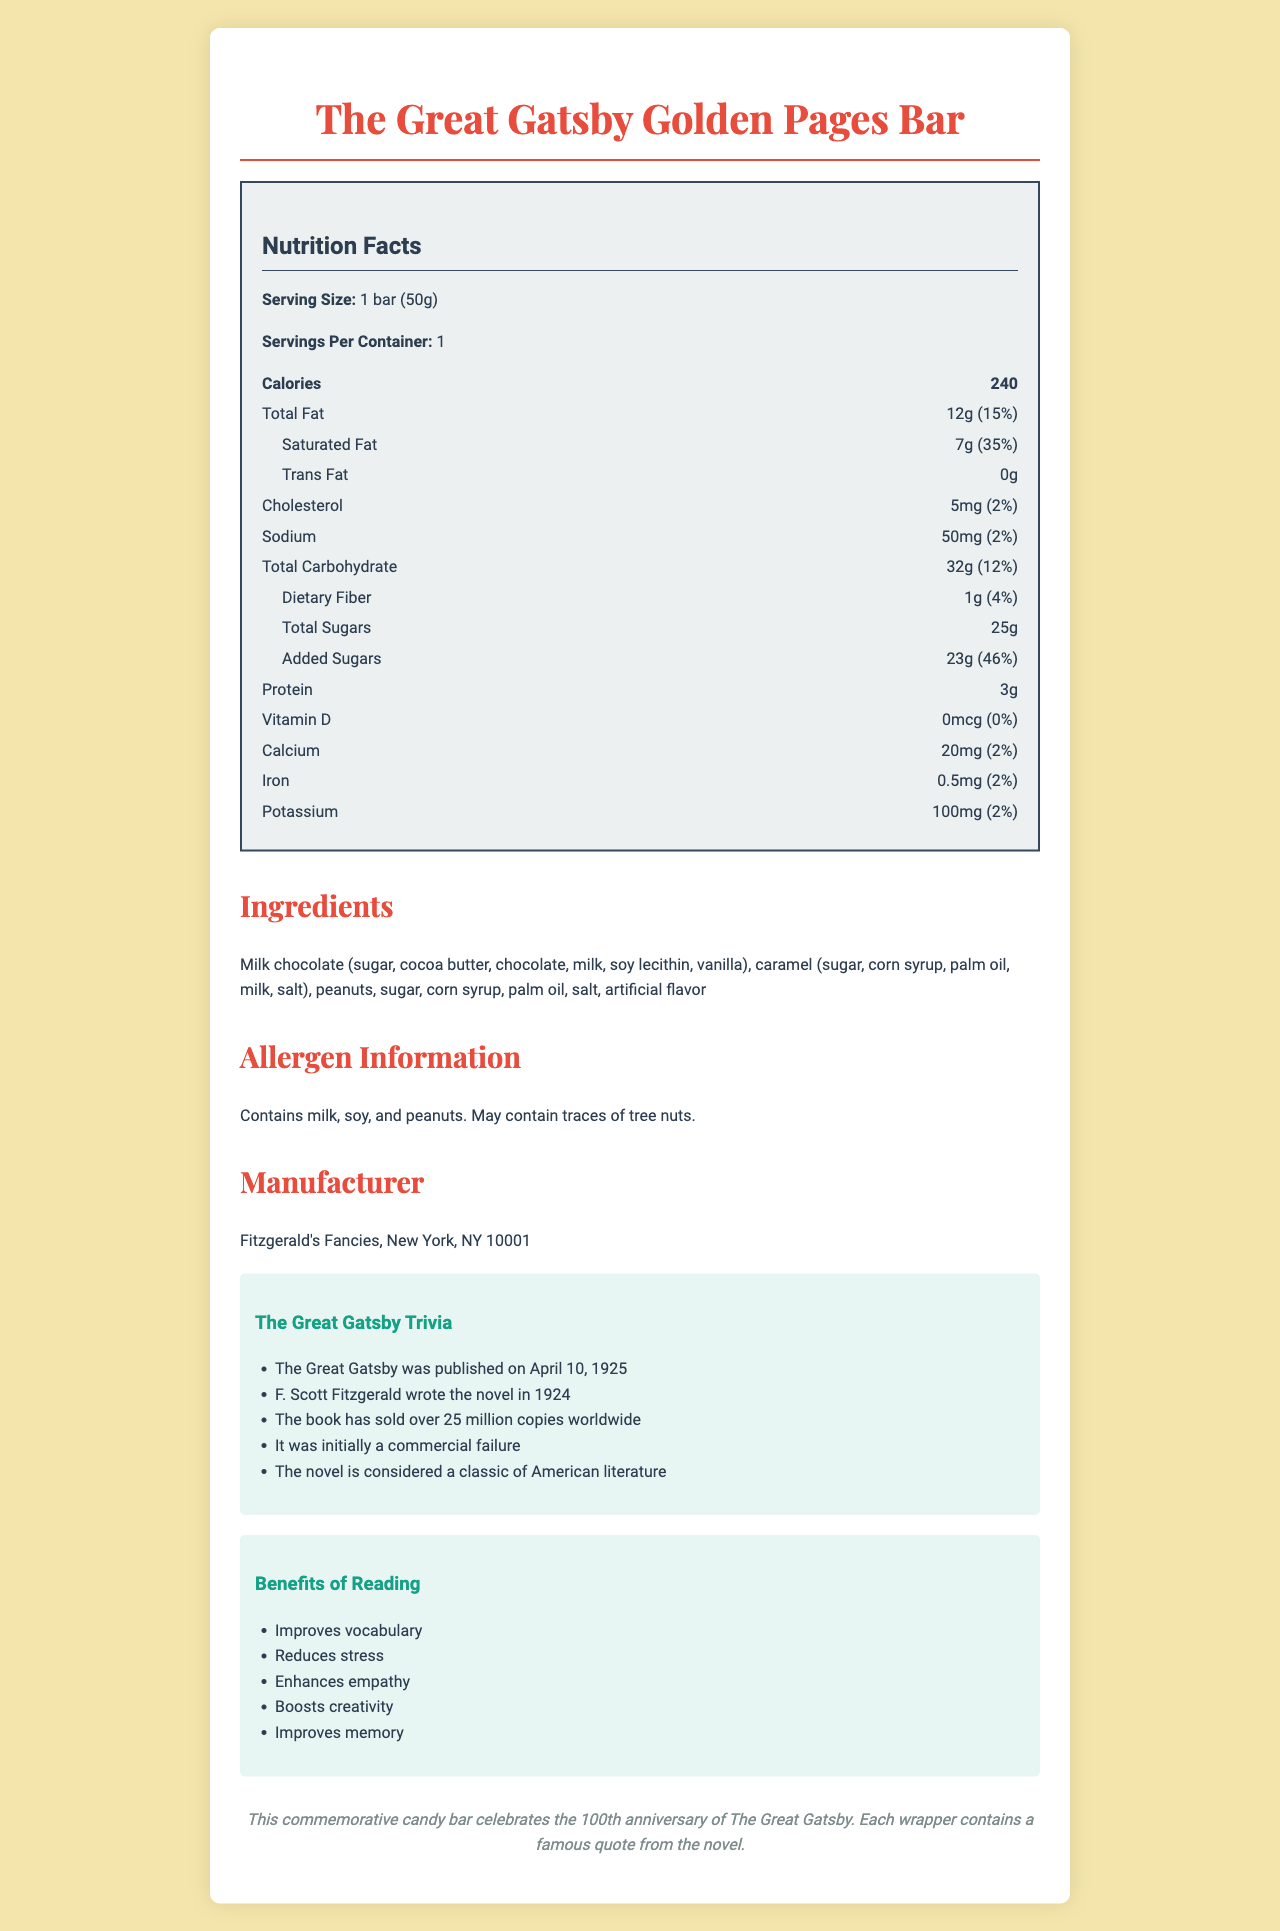what is the serving size of The Great Gatsby Golden Pages Bar? The serving size is explicitly stated as "1 bar (50g)" in the Nutrition Facts section.
Answer: 1 bar (50g) how many calories does one bar contain? The Nutrition Facts section clearly lists the calorie content as 240 calories per bar.
Answer: 240 what is the total fat content per serving? The total fat content is listed as "12g" which is 15% of the daily value, as shown in the Nutrition Facts section.
Answer: 12g (15%) how much saturated fat is in the candy bar? According to the Nutrition Facts section, the saturated fat content is "7g", which is 35% of the daily value.
Answer: 7g (35%) how much added sugar does the candy bar have? The Nutrition Facts section shows the amount of added sugars as "23g", which is 46% of the daily value.
Answer: 23g (46%) how many servings are in one container? A. 1 B. 2 C. 3 D. 4 The document specifies that there is 1 serving per container.
Answer: A what is the amount of sodium in the bar? A: 70mg B: 50mg C: 30mg D: 10mg The sodium content is listed as "50mg" in the Nutrition Facts section.
Answer: B which ingredient is not in the candy bar? A. Milk chocolate B. Caramel C. Peanuts D. Almonds The ingredients list includes milk chocolate, caramel, and peanuts, but not almonds.
Answer: D does the bar contain any Vitamin D? Yes/No The Nutrition Facts section lists the amount of Vitamin D as "0mcg", which is 0% of the daily value.
Answer: No summarize the main components of this document. The document covers various aspects of the candy bar, including its nutritional content, ingredients, allergens, manufacturer, and related trivia about "The Great Gatsby".
Answer: The document provides nutritional information about The Great Gatsby Golden Pages Bar, a special edition candy bar commemorating the 100th anniversary of the publication of "The Great Gatsby". It includes detailed nutrition facts, ingredient list, allergen information, manufacturer details, book trivia, and benefits of reading. what is the main manufacturer of the candy bar? The manufacturer is listed as "Fitzgerald's Fancies, New York, NY 10001" in the document.
Answer: Fitzgerald's Fancies, New York, NY 10001 how much calcium does the candy bar contain per serving? The Nutrition Facts section states that the bar contains "20mg" of calcium, which is 2% of the daily value.
Answer: 20mg (2%) what are some benefits of reading according to the document? The section on the benefits of reading lists these specific advantages.
Answer: Improves vocabulary, Reduces stress, Enhances empathy, Boosts creativity, Improves memory how much iron is in the bar? The amount of iron is listed as "0.5mg" which is 2% of the daily value.
Answer: 0.5mg (2%) how many trivia facts about "The Great Gatsby" are provided? The document provides exactly five trivia facts about "The Great Gatsby".
Answer: 5 what does the special note on the document say? This information can be found at the end of the document under the "Special Note" section.
Answer: This commemorative candy bar celebrates the 100th anniversary of The Great Gatsby. Each wrapper contains a famous quote from the novel. what is the total carbohydrate content of the candy bar? The Nutrition Facts section lists the total carbohydrate content as "32g" which is 12% of the daily value.
Answer: 32g (12%) who is the author of "The Great Gatsby"? The document provides detailed information about the candy bar but does not explicitly mention the author of "The Great Gatsby".
Answer: Not enough information 